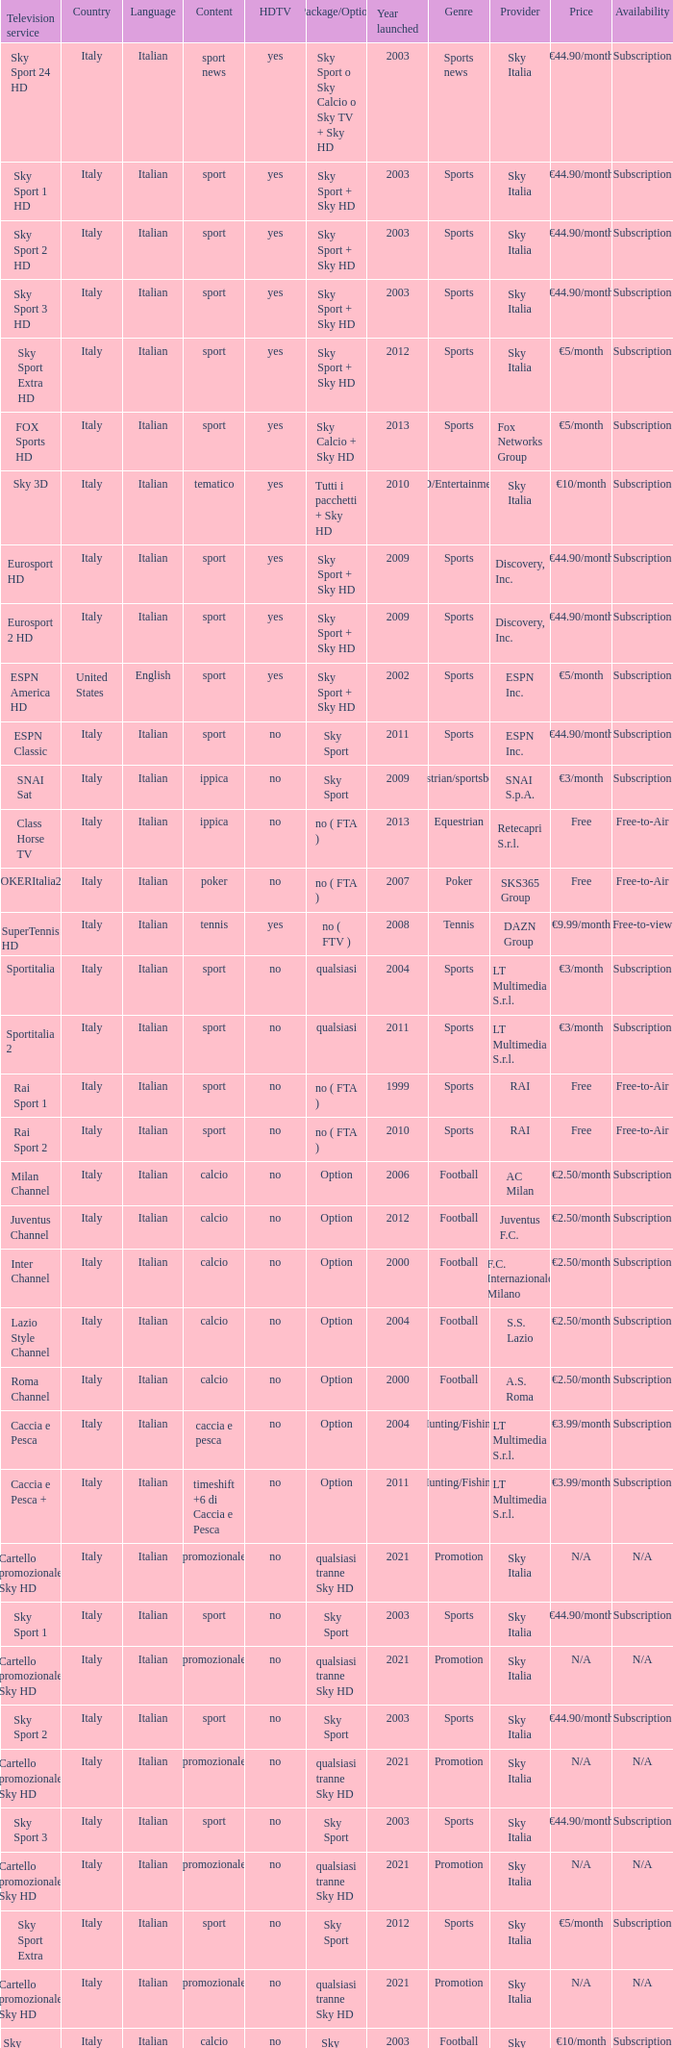What is Language, when Content is Sport, when HDTV is No, and when Television Service is ESPN America? Italian. 